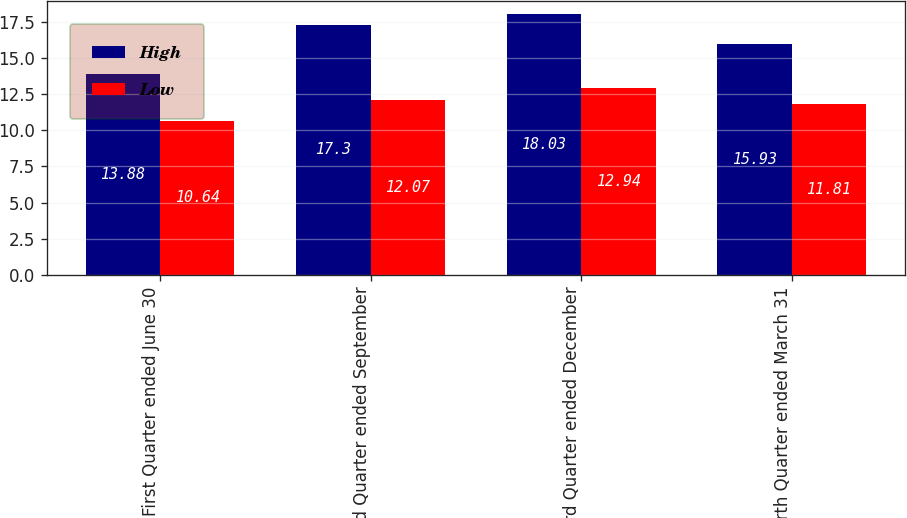Convert chart. <chart><loc_0><loc_0><loc_500><loc_500><stacked_bar_chart><ecel><fcel>First Quarter ended June 30<fcel>Second Quarter ended September<fcel>Third Quarter ended December<fcel>Fourth Quarter ended March 31<nl><fcel>High<fcel>13.88<fcel>17.3<fcel>18.03<fcel>15.93<nl><fcel>Low<fcel>10.64<fcel>12.07<fcel>12.94<fcel>11.81<nl></chart> 